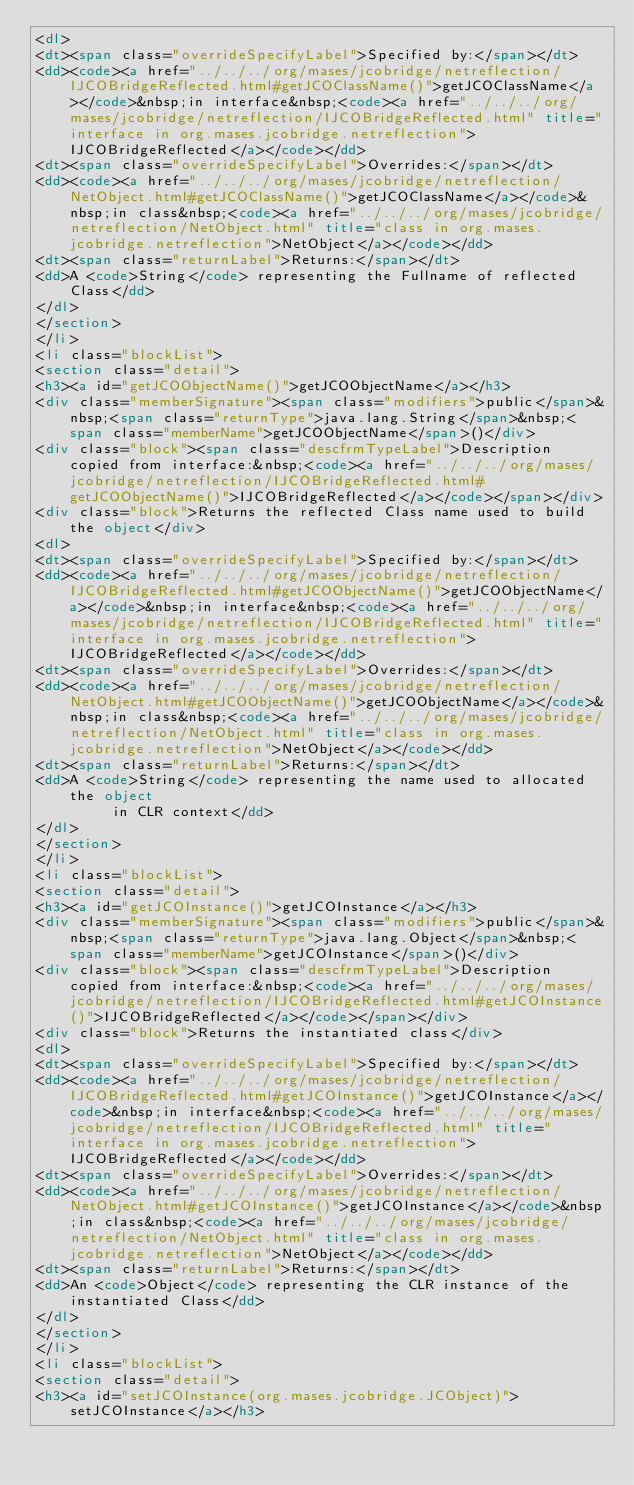Convert code to text. <code><loc_0><loc_0><loc_500><loc_500><_HTML_><dl>
<dt><span class="overrideSpecifyLabel">Specified by:</span></dt>
<dd><code><a href="../../../org/mases/jcobridge/netreflection/IJCOBridgeReflected.html#getJCOClassName()">getJCOClassName</a></code>&nbsp;in interface&nbsp;<code><a href="../../../org/mases/jcobridge/netreflection/IJCOBridgeReflected.html" title="interface in org.mases.jcobridge.netreflection">IJCOBridgeReflected</a></code></dd>
<dt><span class="overrideSpecifyLabel">Overrides:</span></dt>
<dd><code><a href="../../../org/mases/jcobridge/netreflection/NetObject.html#getJCOClassName()">getJCOClassName</a></code>&nbsp;in class&nbsp;<code><a href="../../../org/mases/jcobridge/netreflection/NetObject.html" title="class in org.mases.jcobridge.netreflection">NetObject</a></code></dd>
<dt><span class="returnLabel">Returns:</span></dt>
<dd>A <code>String</code> representing the Fullname of reflected Class</dd>
</dl>
</section>
</li>
<li class="blockList">
<section class="detail">
<h3><a id="getJCOObjectName()">getJCOObjectName</a></h3>
<div class="memberSignature"><span class="modifiers">public</span>&nbsp;<span class="returnType">java.lang.String</span>&nbsp;<span class="memberName">getJCOObjectName</span>()</div>
<div class="block"><span class="descfrmTypeLabel">Description copied from interface:&nbsp;<code><a href="../../../org/mases/jcobridge/netreflection/IJCOBridgeReflected.html#getJCOObjectName()">IJCOBridgeReflected</a></code></span></div>
<div class="block">Returns the reflected Class name used to build the object</div>
<dl>
<dt><span class="overrideSpecifyLabel">Specified by:</span></dt>
<dd><code><a href="../../../org/mases/jcobridge/netreflection/IJCOBridgeReflected.html#getJCOObjectName()">getJCOObjectName</a></code>&nbsp;in interface&nbsp;<code><a href="../../../org/mases/jcobridge/netreflection/IJCOBridgeReflected.html" title="interface in org.mases.jcobridge.netreflection">IJCOBridgeReflected</a></code></dd>
<dt><span class="overrideSpecifyLabel">Overrides:</span></dt>
<dd><code><a href="../../../org/mases/jcobridge/netreflection/NetObject.html#getJCOObjectName()">getJCOObjectName</a></code>&nbsp;in class&nbsp;<code><a href="../../../org/mases/jcobridge/netreflection/NetObject.html" title="class in org.mases.jcobridge.netreflection">NetObject</a></code></dd>
<dt><span class="returnLabel">Returns:</span></dt>
<dd>A <code>String</code> representing the name used to allocated the object
         in CLR context</dd>
</dl>
</section>
</li>
<li class="blockList">
<section class="detail">
<h3><a id="getJCOInstance()">getJCOInstance</a></h3>
<div class="memberSignature"><span class="modifiers">public</span>&nbsp;<span class="returnType">java.lang.Object</span>&nbsp;<span class="memberName">getJCOInstance</span>()</div>
<div class="block"><span class="descfrmTypeLabel">Description copied from interface:&nbsp;<code><a href="../../../org/mases/jcobridge/netreflection/IJCOBridgeReflected.html#getJCOInstance()">IJCOBridgeReflected</a></code></span></div>
<div class="block">Returns the instantiated class</div>
<dl>
<dt><span class="overrideSpecifyLabel">Specified by:</span></dt>
<dd><code><a href="../../../org/mases/jcobridge/netreflection/IJCOBridgeReflected.html#getJCOInstance()">getJCOInstance</a></code>&nbsp;in interface&nbsp;<code><a href="../../../org/mases/jcobridge/netreflection/IJCOBridgeReflected.html" title="interface in org.mases.jcobridge.netreflection">IJCOBridgeReflected</a></code></dd>
<dt><span class="overrideSpecifyLabel">Overrides:</span></dt>
<dd><code><a href="../../../org/mases/jcobridge/netreflection/NetObject.html#getJCOInstance()">getJCOInstance</a></code>&nbsp;in class&nbsp;<code><a href="../../../org/mases/jcobridge/netreflection/NetObject.html" title="class in org.mases.jcobridge.netreflection">NetObject</a></code></dd>
<dt><span class="returnLabel">Returns:</span></dt>
<dd>An <code>Object</code> representing the CLR instance of the instantiated Class</dd>
</dl>
</section>
</li>
<li class="blockList">
<section class="detail">
<h3><a id="setJCOInstance(org.mases.jcobridge.JCObject)">setJCOInstance</a></h3></code> 